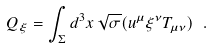Convert formula to latex. <formula><loc_0><loc_0><loc_500><loc_500>Q _ { \xi } = \int _ { \Sigma } d ^ { 3 } x \, \sqrt { \sigma } ( u ^ { \mu } \xi ^ { \nu } T _ { \mu \nu } ) \ .</formula> 